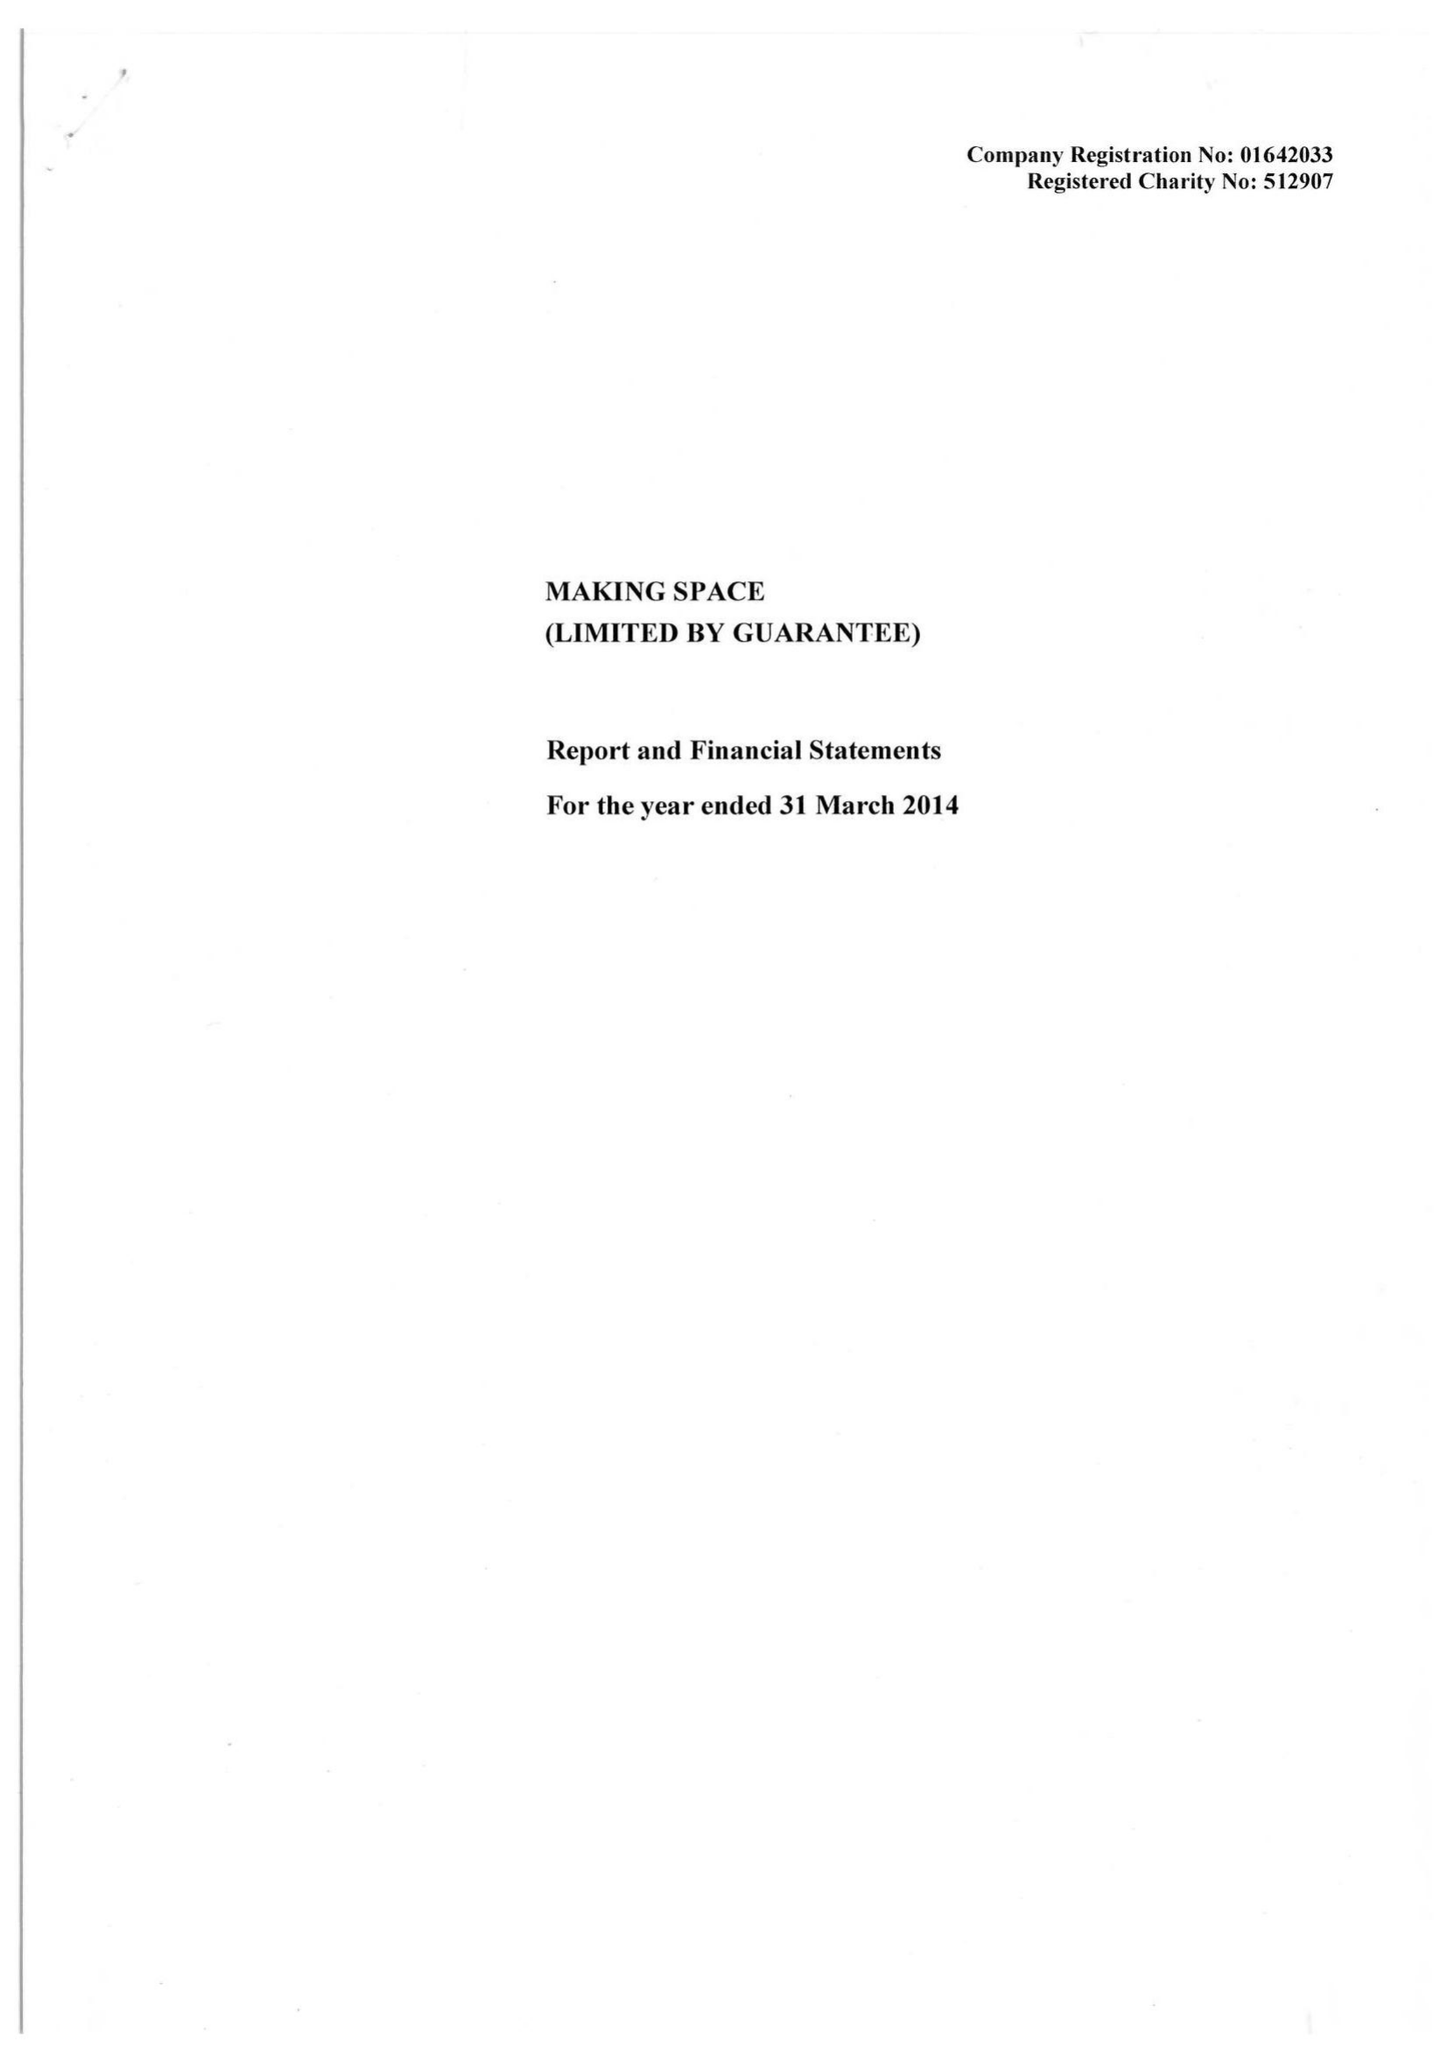What is the value for the address__post_town?
Answer the question using a single word or phrase. WARRINGTON 